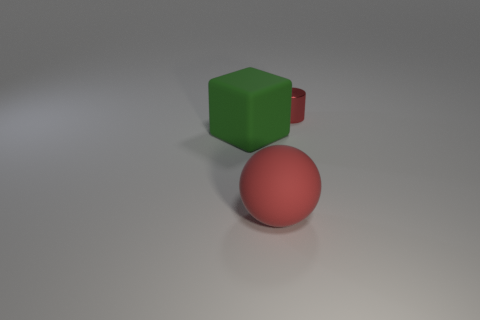Add 3 big balls. How many objects exist? 6 Subtract all spheres. How many objects are left? 2 Subtract 0 cyan spheres. How many objects are left? 3 Subtract all tiny red spheres. Subtract all small shiny objects. How many objects are left? 2 Add 3 red metal things. How many red metal things are left? 4 Add 1 red cylinders. How many red cylinders exist? 2 